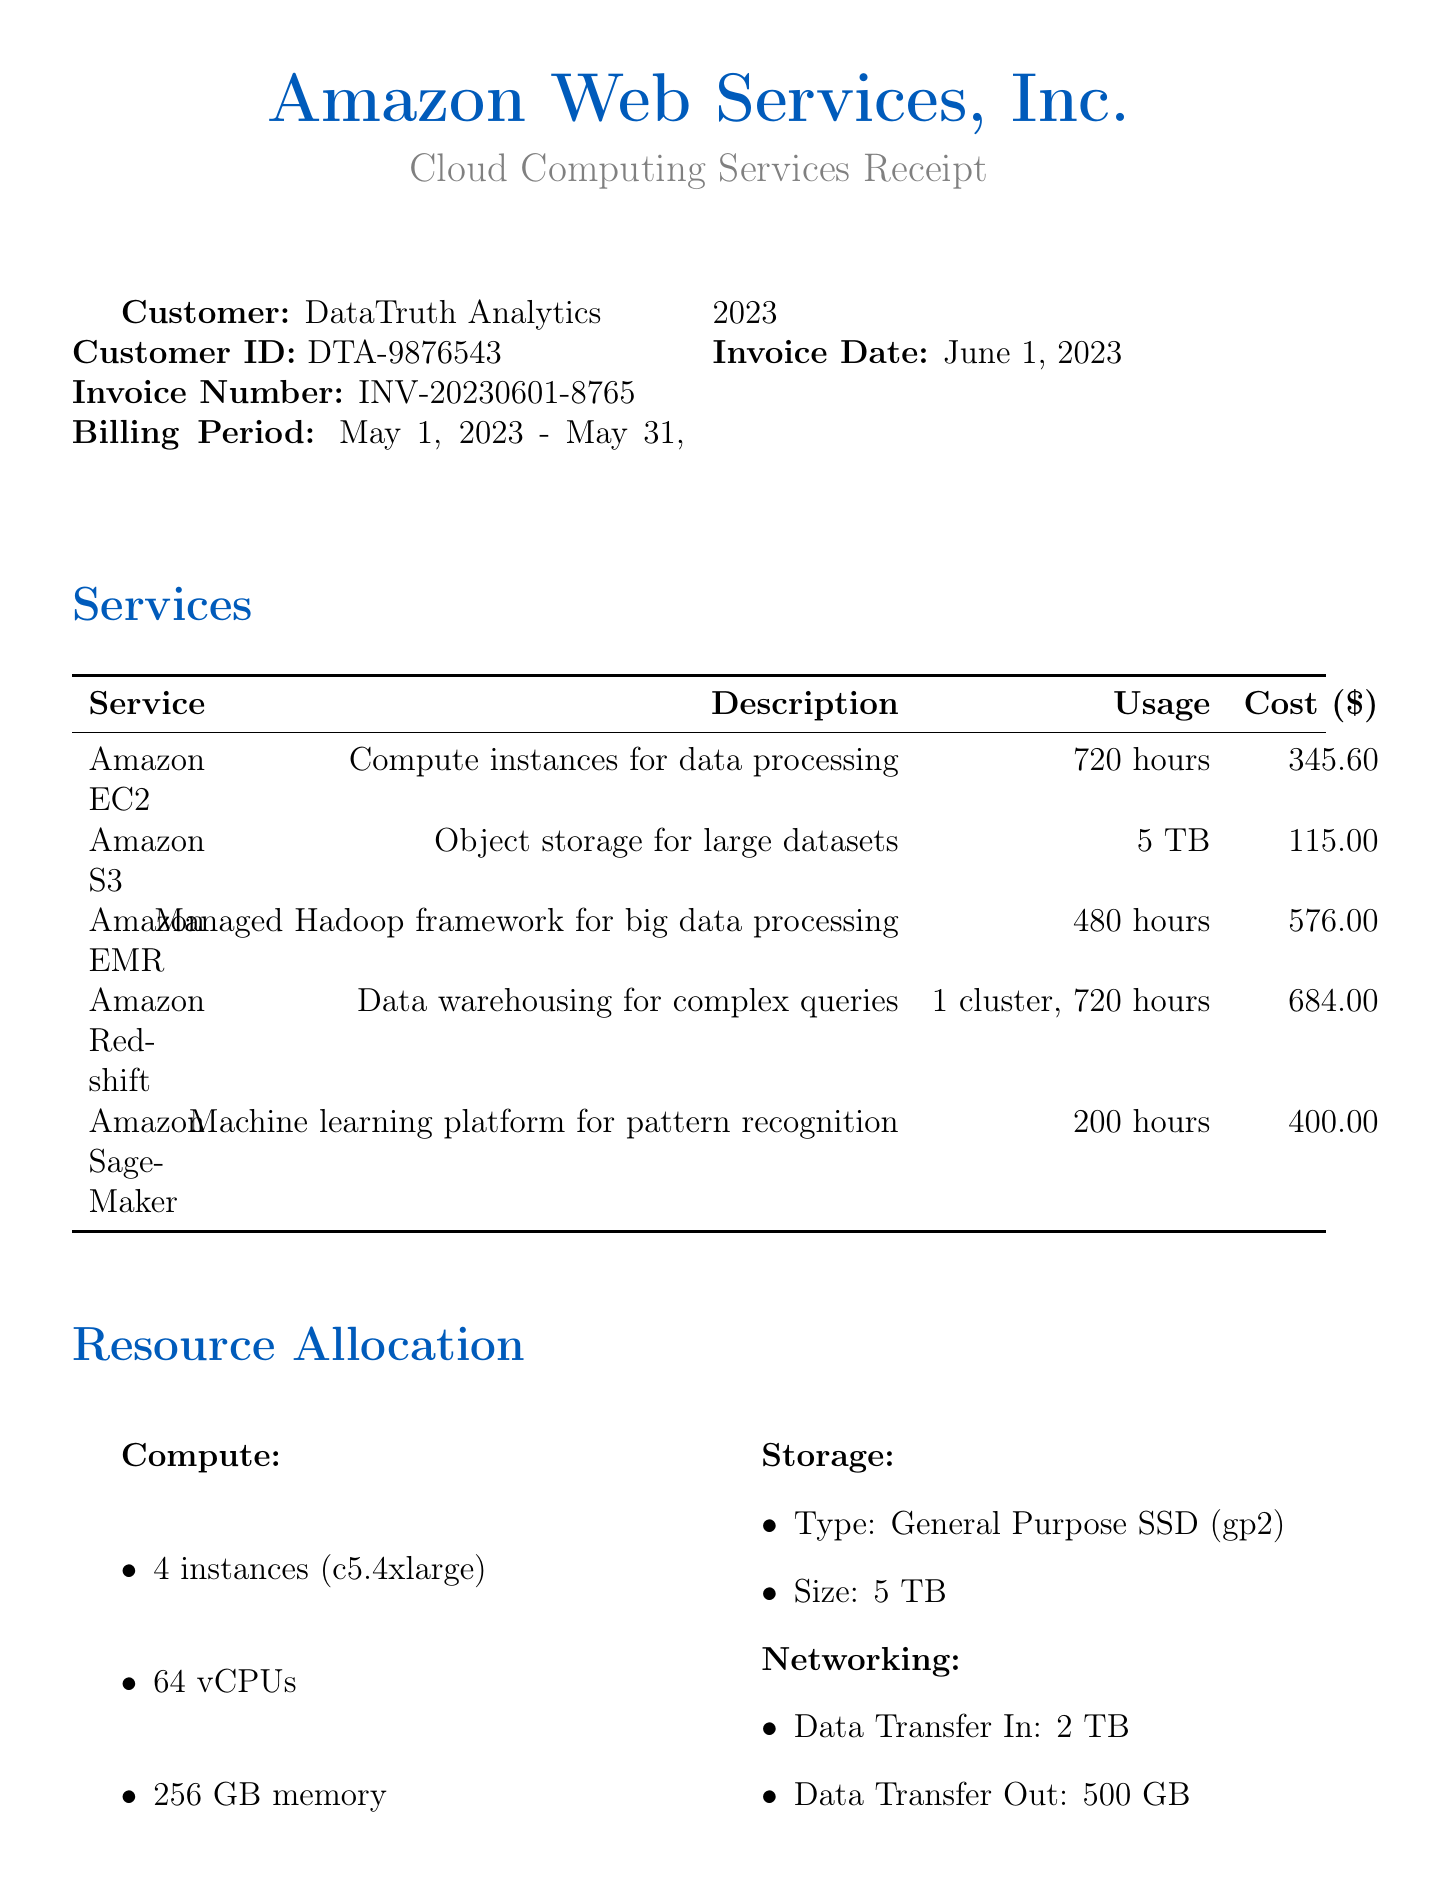what is the customer name? The customer name is specified in the document, which is DataTruth Analytics.
Answer: DataTruth Analytics what is the invoice date? The invoice date is provided in the document, which is June 1, 2023.
Answer: June 1, 2023 what is the total cost? The total cost is clearly listed in the document, which sums up the individual service costs.
Answer: 2741.60 how many instances were allocated for compute? The document specifies the number of instances allocated for compute resources.
Answer: 4 what service is used for machine learning? The document lists services, and the one dedicated to machine learning is specified.
Answer: Amazon SageMaker what is the usage for Amazon Redshift? The document provides the usage details for Amazon Redshift, specifically in terms of clusters and hours.
Answer: 1 cluster, 720 hours what is the payment terms? The payment terms are explicitly mentioned in the document.
Answer: Due within 30 days how much did DataTruth Analytics spend on data transfer? The document breaks down costs and specifies the cost associated with data transfer.
Answer: 45.00 what period does this invoice cover? The billing period is clearly defined in the document, covering specific dates.
Answer: May 1, 2023 - May 31, 2023 